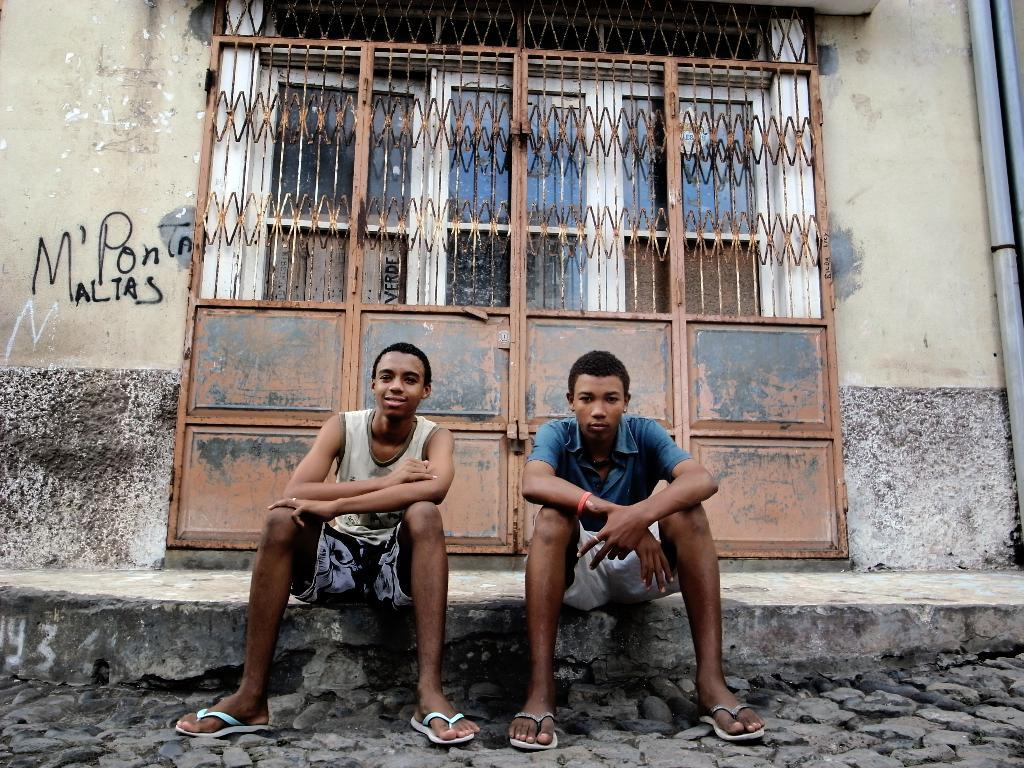How many people are in the image? There are two boys in the image. What are the boys doing in the image? The boys are sitting on the floor. What type of clothing are the boys wearing? The boys are wearing shorts and chappals. What can be seen in the background of the image? There is an iron gate in the background of the image. What type of rhythm can be heard from the sheep in the image? There are no sheep present in the image, so there is no rhythm to be heard. How many girls are in the image? The image only features two boys, so there are no girls present. 